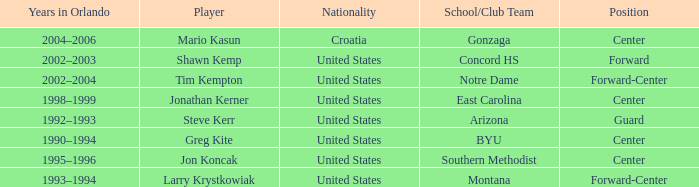Which player has montana as the school/club team? Larry Krystkowiak. Help me parse the entirety of this table. {'header': ['Years in Orlando', 'Player', 'Nationality', 'School/Club Team', 'Position'], 'rows': [['2004–2006', 'Mario Kasun', 'Croatia', 'Gonzaga', 'Center'], ['2002–2003', 'Shawn Kemp', 'United States', 'Concord HS', 'Forward'], ['2002–2004', 'Tim Kempton', 'United States', 'Notre Dame', 'Forward-Center'], ['1998–1999', 'Jonathan Kerner', 'United States', 'East Carolina', 'Center'], ['1992–1993', 'Steve Kerr', 'United States', 'Arizona', 'Guard'], ['1990–1994', 'Greg Kite', 'United States', 'BYU', 'Center'], ['1995–1996', 'Jon Koncak', 'United States', 'Southern Methodist', 'Center'], ['1993–1994', 'Larry Krystkowiak', 'United States', 'Montana', 'Forward-Center']]} 